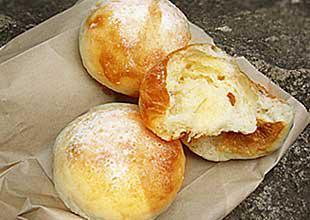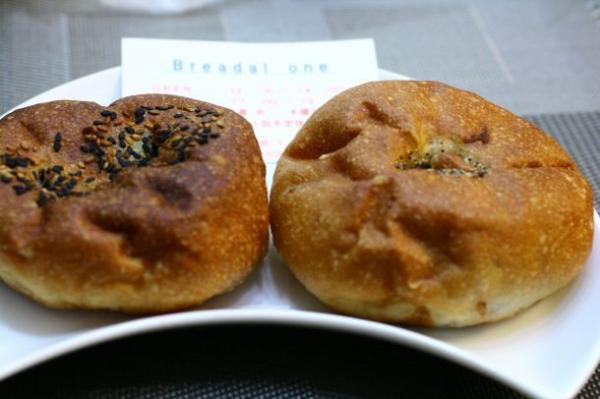The first image is the image on the left, the second image is the image on the right. For the images shown, is this caption "One image contains exactly two round roll-type items displayed horizontally and side-by-side." true? Answer yes or no. Yes. The first image is the image on the left, the second image is the image on the right. Examine the images to the left and right. Is the description "There are no more than five pastries." accurate? Answer yes or no. Yes. 